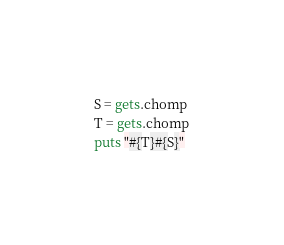<code> <loc_0><loc_0><loc_500><loc_500><_Ruby_>S = gets.chomp
T = gets.chomp
puts "#{T}#{S}" </code> 